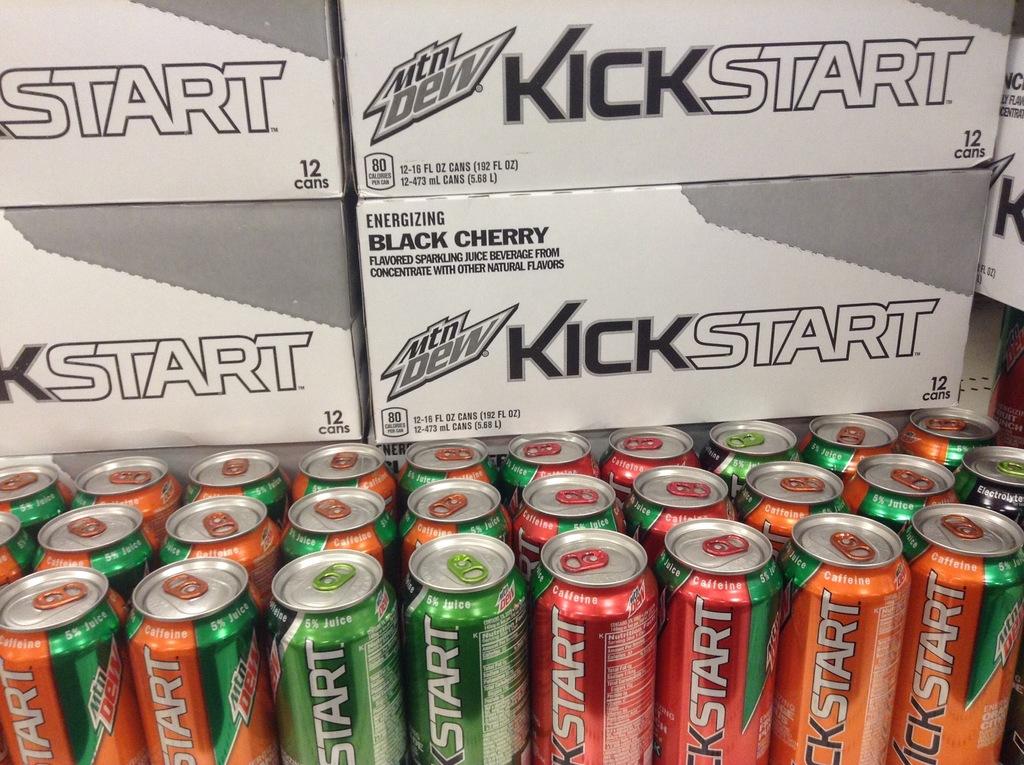What flavor of soda is written on the box in the back?
Provide a short and direct response. Black cherry. 